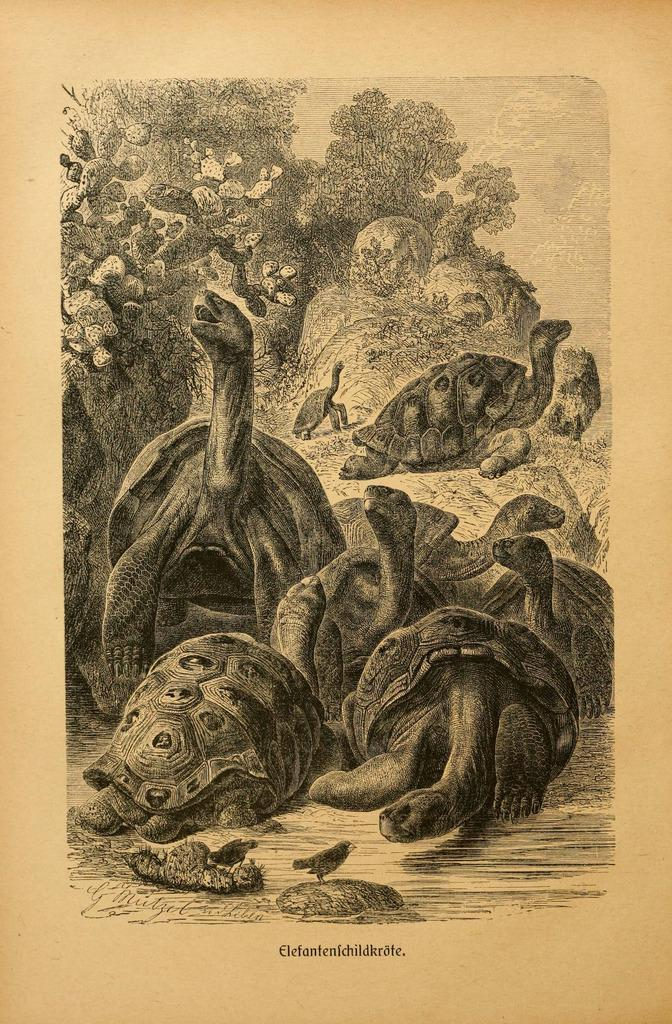What is depicted on the paper in the image? There is a printed image on a paper in the image. What type of natural environment can be seen in the image? There are trees visible in the image. What type of living organisms are present in the image? There are animals and birds in the image. What is written or printed at the bottom of the image? There is text at the bottom of the image. What color of paint is being used by the eye in the image? There is no paint or eye present in the image. 